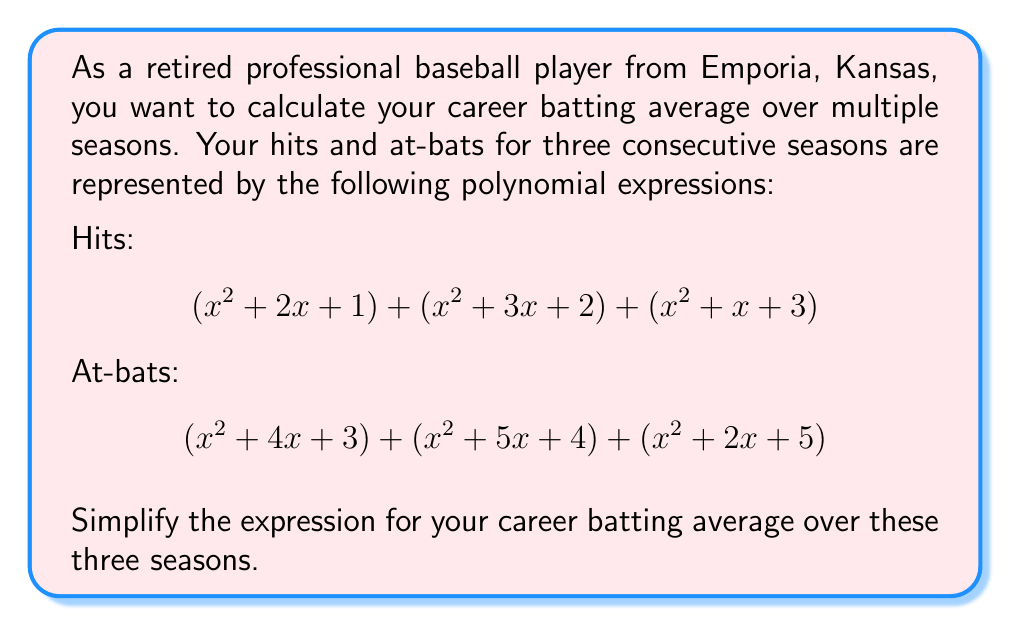Give your solution to this math problem. Let's approach this step-by-step:

1) First, let's simplify the numerator (total hits):
   $$(x^2 + 2x + 1) + (x^2 + 3x + 2) + (x^2 + x + 3)$$
   $$= 3x^2 + 6x + 6$$

2) Now, let's simplify the denominator (total at-bats):
   $$(x^2 + 4x + 3) + (x^2 + 5x + 4) + (x^2 + 2x + 5)$$
   $$= 3x^2 + 11x + 12$$

3) The batting average is calculated by dividing hits by at-bats:

   $$\text{Batting Average} = \frac{\text{Hits}}{\text{At-bats}} = \frac{3x^2 + 6x + 6}{3x^2 + 11x + 12}$$

4) This fraction cannot be simplified further as the numerator and denominator have no common factors.

Therefore, the simplified expression for the career batting average over these three seasons is:

$$\frac{3x^2 + 6x + 6}{3x^2 + 11x + 12}$$
Answer: $$\frac{3x^2 + 6x + 6}{3x^2 + 11x + 12}$$ 